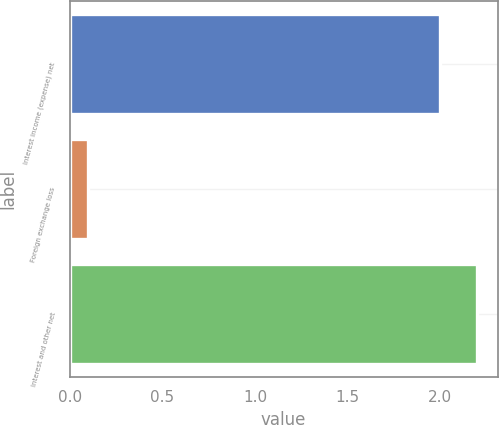Convert chart. <chart><loc_0><loc_0><loc_500><loc_500><bar_chart><fcel>Interest income (expense) net<fcel>Foreign exchange loss<fcel>Interest and other net<nl><fcel>2<fcel>0.1<fcel>2.2<nl></chart> 